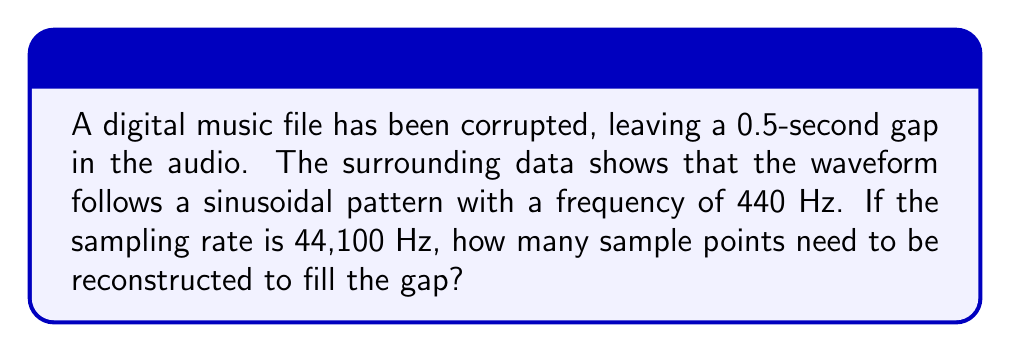Give your solution to this math problem. To solve this problem, we need to follow these steps:

1. Calculate the number of samples in one second:
   The sampling rate is 44,100 Hz, which means there are 44,100 samples per second.

2. Calculate the number of samples in 0.5 seconds:
   $$\text{Samples in gap} = \text{Sampling rate} \times \text{Gap duration}$$
   $$\text{Samples in gap} = 44,100 \text{ Hz} \times 0.5 \text{ s}$$
   $$\text{Samples in gap} = 22,050 \text{ samples}$$

3. Verify that this number of samples is sufficient to reconstruct the waveform:
   The Nyquist-Shannon sampling theorem states that to accurately reconstruct a signal, the sampling rate must be at least twice the highest frequency in the signal.

   In this case:
   $$\text{Minimum sampling rate} = 2 \times 440 \text{ Hz} = 880 \text{ Hz}$$

   Our actual sampling rate (44,100 Hz) is much higher than the minimum required, so we can accurately reconstruct the signal.

Therefore, we need to reconstruct 22,050 sample points to fill the 0.5-second gap in the digital music file.
Answer: 22,050 samples 